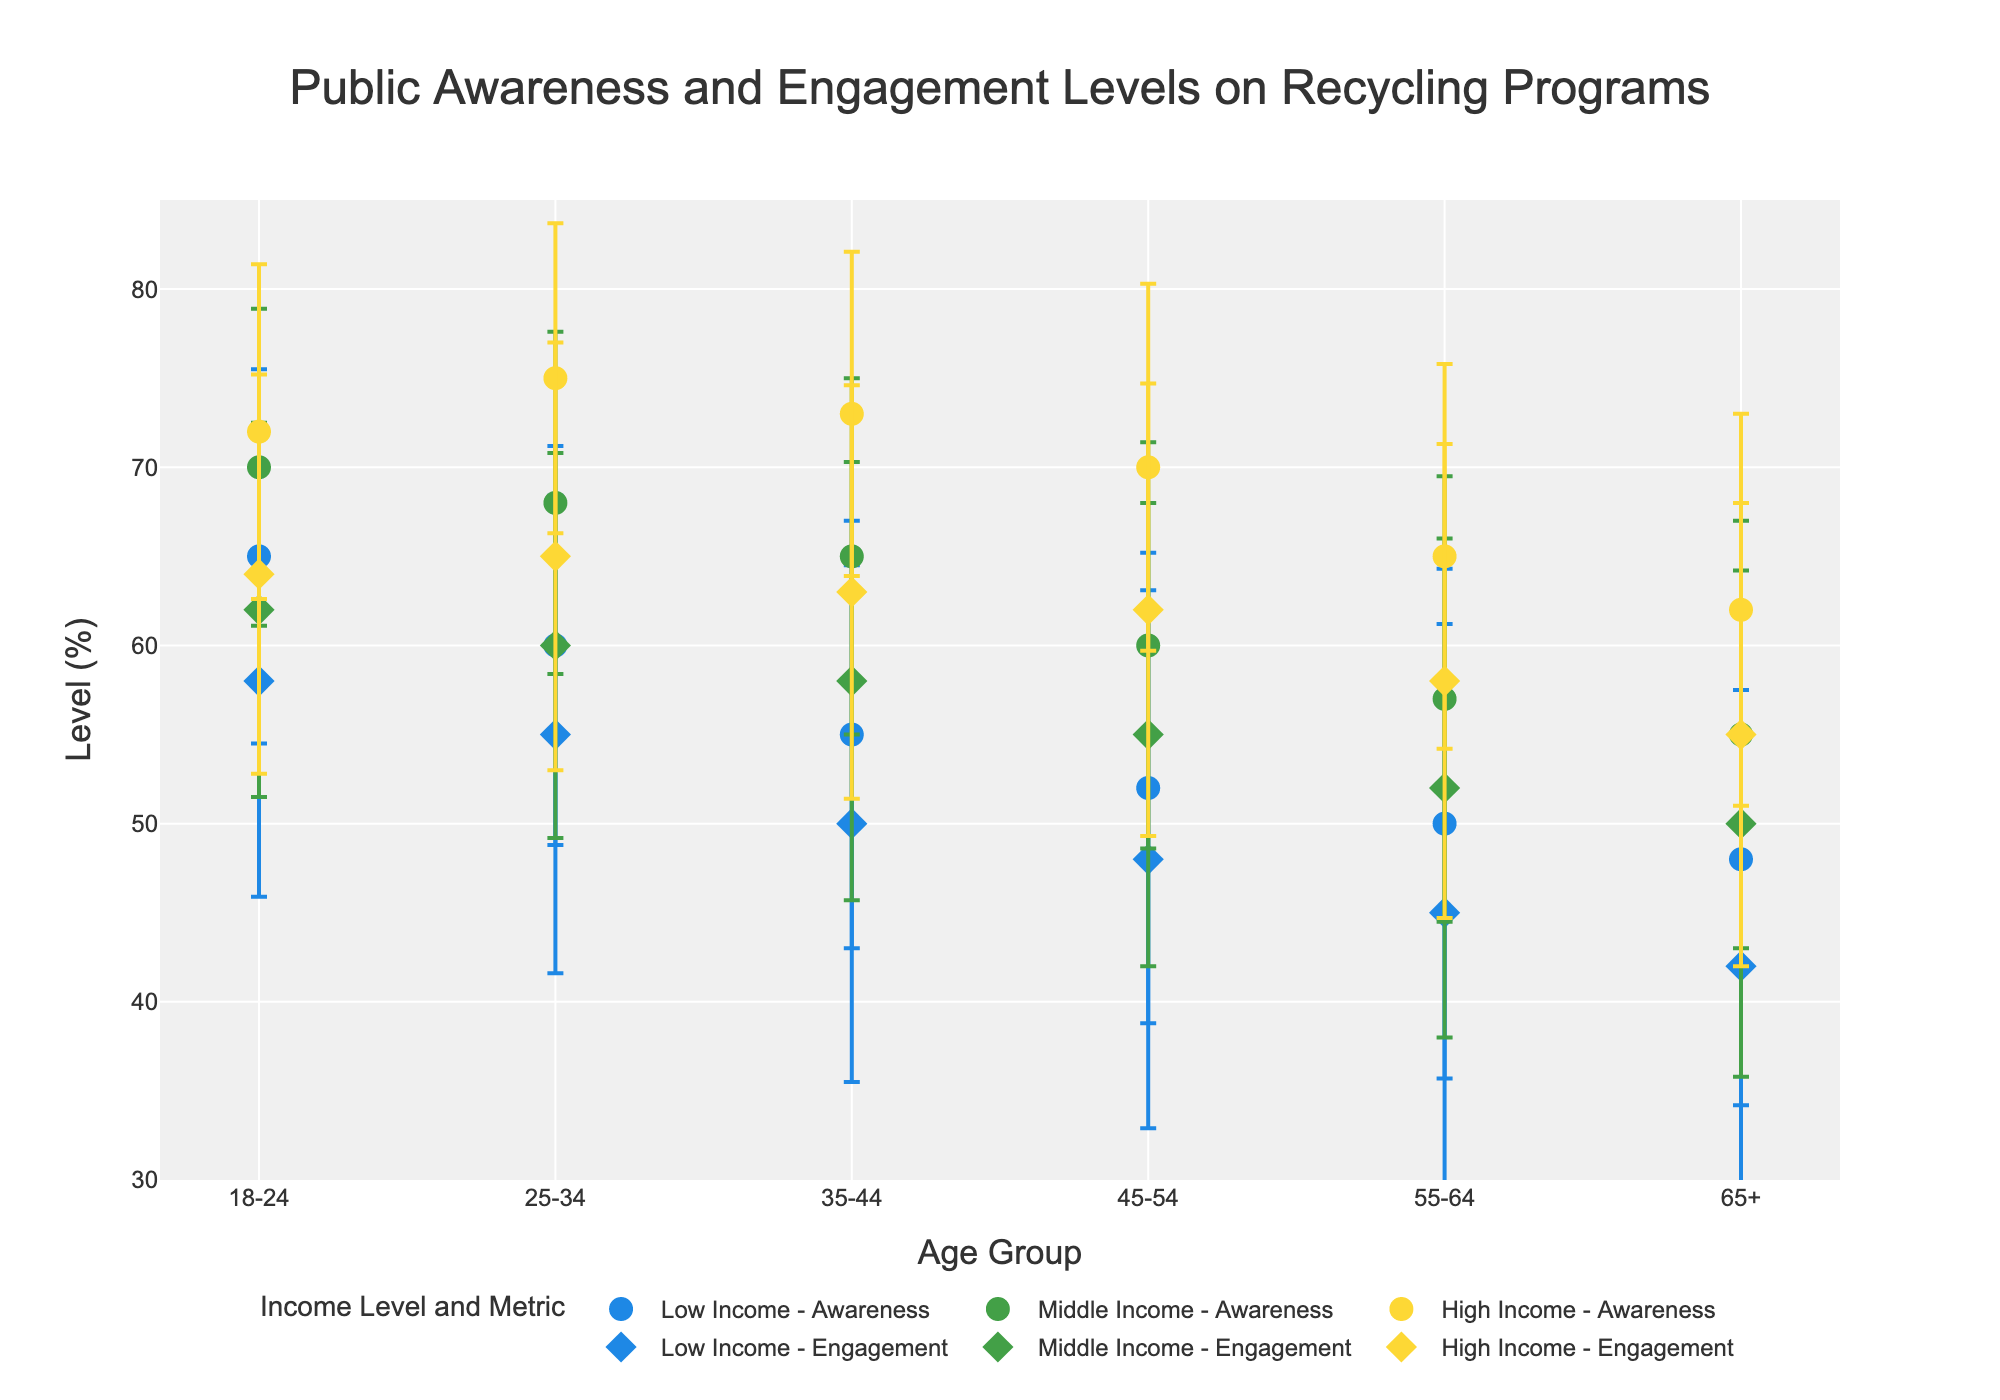What's the title of the plot? The title is usually displayed prominently somewhere at the top of the plot. By reading it directly, we identify that it states "Public Awareness and Engagement Levels on Recycling Programs".
Answer: Public Awareness and Engagement Levels on Recycling Programs What is the average Public Awareness level for the 18-24 age group with middle income? Locate the dot corresponding to the 18-24 age group and middle income level in the "Public Awareness" section of the plot. The value is directly labeled.
Answer: 70 Which age group has the lowest Engagement Level for the high income category? Look for the "High Income - Engagement" markers across the different age groups. Compare the values and determine the lowest one by checking the y-axis.
Answer: 65+ What is the range of Public Awareness average levels for the 35-44 age group? To determine the range, identify the highest and lowest Public Awareness average levels for the 35-44 age group, then subtract the smallest from the largest. The values are 73 and 55.
Answer: 18 How does the Public Awareness level of the 55-64 age group with low income compare to that of the 18-24 age group with low income? Analyze the points related to the low-income category for both age groups in the Public Awareness section. The 18-24 age group has a higher Public Awareness level (65 vs. 50).
Answer: 18-24 is higher What is the difference between the Engagement Level of the 25-34 age group with middle income and the 45-54 age group with high income? Identify and subtract the Engagement Levels for the specific age groups and income levels. 60 for 25-34 middle income and 62 for 45-54 high income (62 - 60).
Answer: 2 What pattern do you observe comparing Public Awareness and Engagement Levels across different age groups within the high income level? Review the plot markers for high income across different age groups. Typically, engagement levels increase with age until a certain point and then decrease in older age groups. Public Awareness generally follows a positive trend as well.
Answer: Both follow a general increasing trend and then decrease Does the Engagement Level for high income individuals stay consistent across all age groups? By looking solely at the "High Income - Engagement" markers across all age groups, you can see that it varies, with no sign of stability.
Answer: No Which demographic group has the highest standard deviation in Public Awareness? Review the error bars representing the standard deviations for all demographics. The highest error bar will indicate the group with the greatest standard deviation.
Answer: 55-64 with low income 